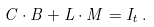<formula> <loc_0><loc_0><loc_500><loc_500>C \cdot B + L \cdot M = I _ { t } \, .</formula> 